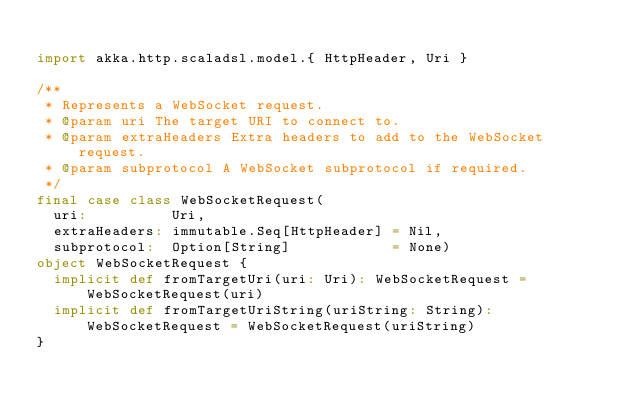Convert code to text. <code><loc_0><loc_0><loc_500><loc_500><_Scala_>
import akka.http.scaladsl.model.{ HttpHeader, Uri }

/**
 * Represents a WebSocket request.
 * @param uri The target URI to connect to.
 * @param extraHeaders Extra headers to add to the WebSocket request.
 * @param subprotocol A WebSocket subprotocol if required.
 */
final case class WebSocketRequest(
  uri:          Uri,
  extraHeaders: immutable.Seq[HttpHeader] = Nil,
  subprotocol:  Option[String]            = None)
object WebSocketRequest {
  implicit def fromTargetUri(uri: Uri): WebSocketRequest = WebSocketRequest(uri)
  implicit def fromTargetUriString(uriString: String): WebSocketRequest = WebSocketRequest(uriString)
}
</code> 